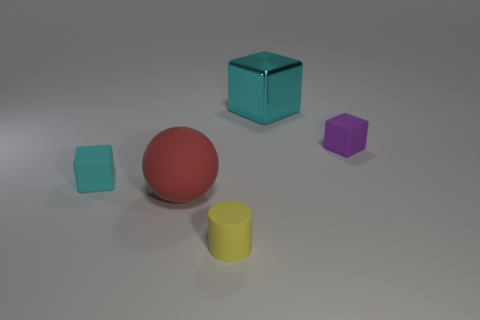Add 3 large blue matte cylinders. How many objects exist? 8 Subtract all small purple rubber blocks. How many blocks are left? 2 Add 2 purple cylinders. How many purple cylinders exist? 2 Subtract all cyan blocks. How many blocks are left? 1 Subtract 0 brown cylinders. How many objects are left? 5 Subtract all cylinders. How many objects are left? 4 Subtract 1 cubes. How many cubes are left? 2 Subtract all cyan cylinders. Subtract all cyan balls. How many cylinders are left? 1 Subtract all green cubes. How many cyan spheres are left? 0 Subtract all tiny purple balls. Subtract all rubber things. How many objects are left? 1 